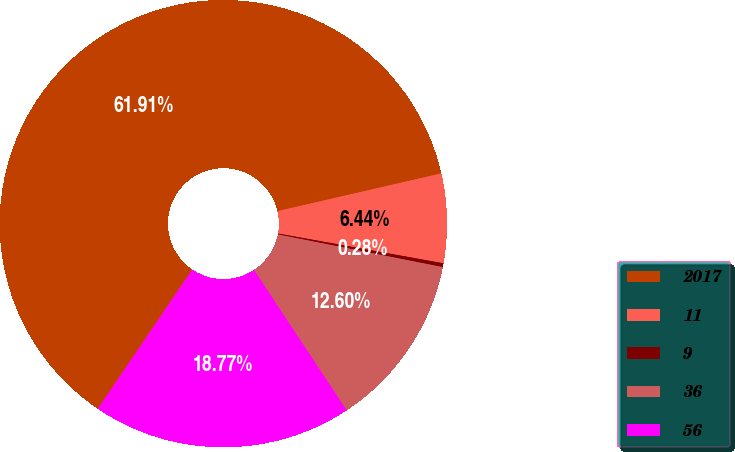Convert chart. <chart><loc_0><loc_0><loc_500><loc_500><pie_chart><fcel>2017<fcel>11<fcel>9<fcel>36<fcel>56<nl><fcel>61.91%<fcel>6.44%<fcel>0.28%<fcel>12.6%<fcel>18.77%<nl></chart> 